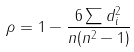<formula> <loc_0><loc_0><loc_500><loc_500>\rho = 1 - \frac { 6 \sum d _ { i } ^ { 2 } } { n ( n ^ { 2 } - 1 ) }</formula> 